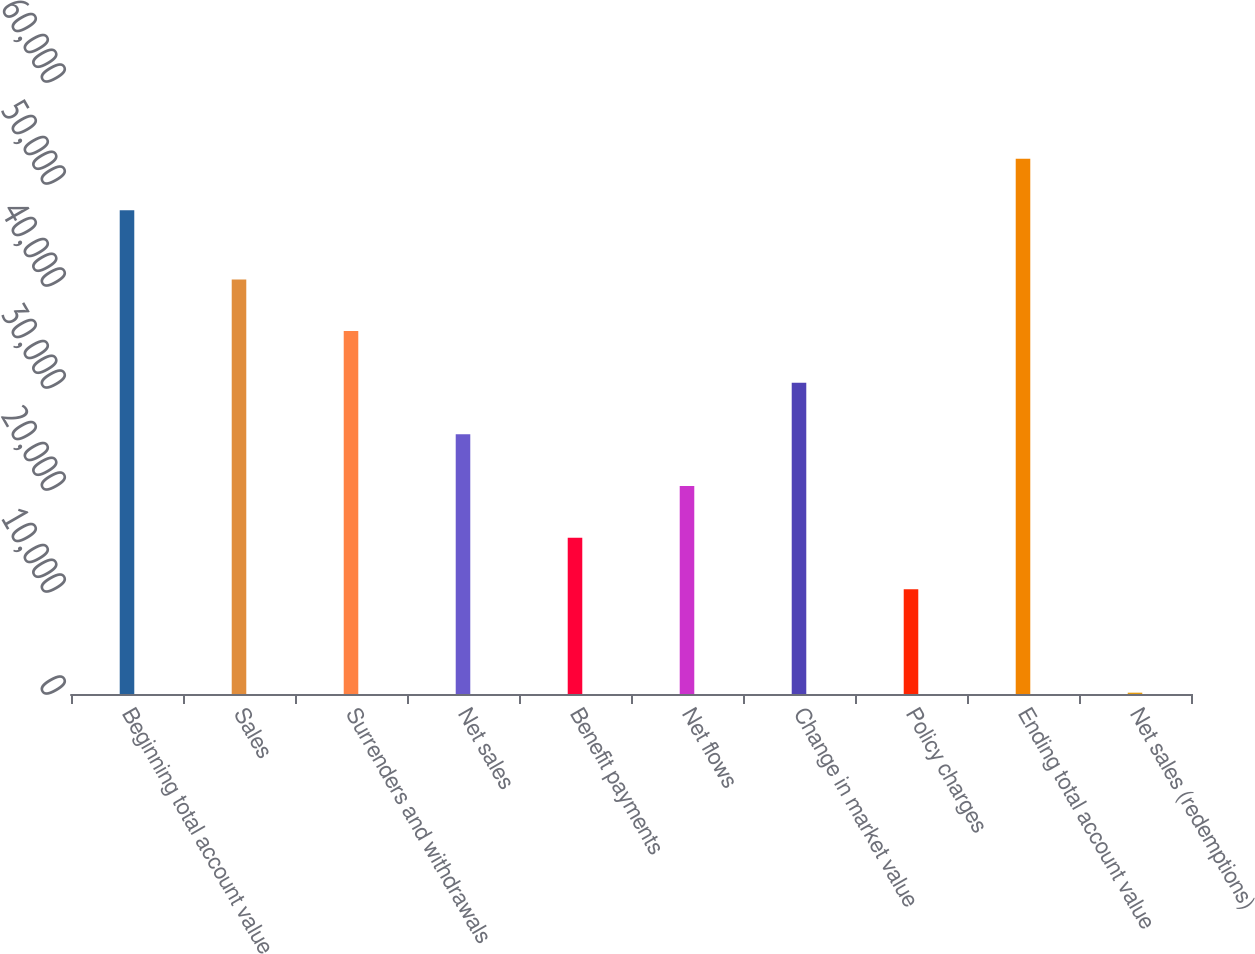Convert chart. <chart><loc_0><loc_0><loc_500><loc_500><bar_chart><fcel>Beginning total account value<fcel>Sales<fcel>Surrenders and withdrawals<fcel>Net sales<fcel>Benefit payments<fcel>Net flows<fcel>Change in market value<fcel>Policy charges<fcel>Ending total account value<fcel>Net sales (redemptions)<nl><fcel>47418<fcel>40648.4<fcel>35583.6<fcel>25454<fcel>15324.4<fcel>20389.2<fcel>30518.8<fcel>10259.6<fcel>52482.8<fcel>130<nl></chart> 